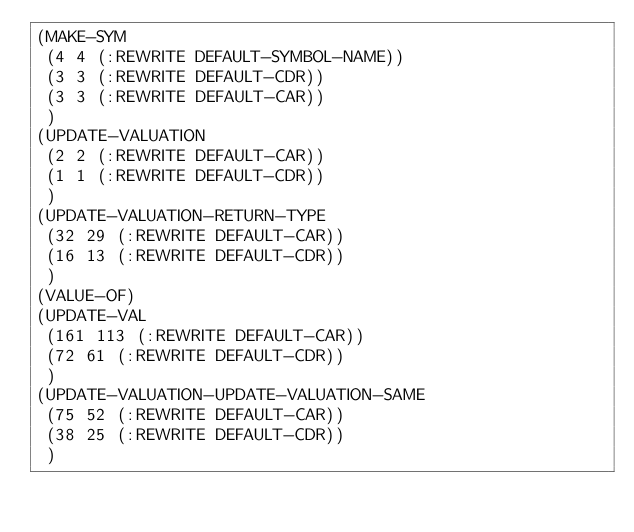<code> <loc_0><loc_0><loc_500><loc_500><_Lisp_>(MAKE-SYM
 (4 4 (:REWRITE DEFAULT-SYMBOL-NAME))
 (3 3 (:REWRITE DEFAULT-CDR))
 (3 3 (:REWRITE DEFAULT-CAR))
 )
(UPDATE-VALUATION
 (2 2 (:REWRITE DEFAULT-CAR))
 (1 1 (:REWRITE DEFAULT-CDR))
 )
(UPDATE-VALUATION-RETURN-TYPE
 (32 29 (:REWRITE DEFAULT-CAR))
 (16 13 (:REWRITE DEFAULT-CDR))
 )
(VALUE-OF)
(UPDATE-VAL
 (161 113 (:REWRITE DEFAULT-CAR))
 (72 61 (:REWRITE DEFAULT-CDR))
 )
(UPDATE-VALUATION-UPDATE-VALUATION-SAME
 (75 52 (:REWRITE DEFAULT-CAR))
 (38 25 (:REWRITE DEFAULT-CDR))
 )
</code> 